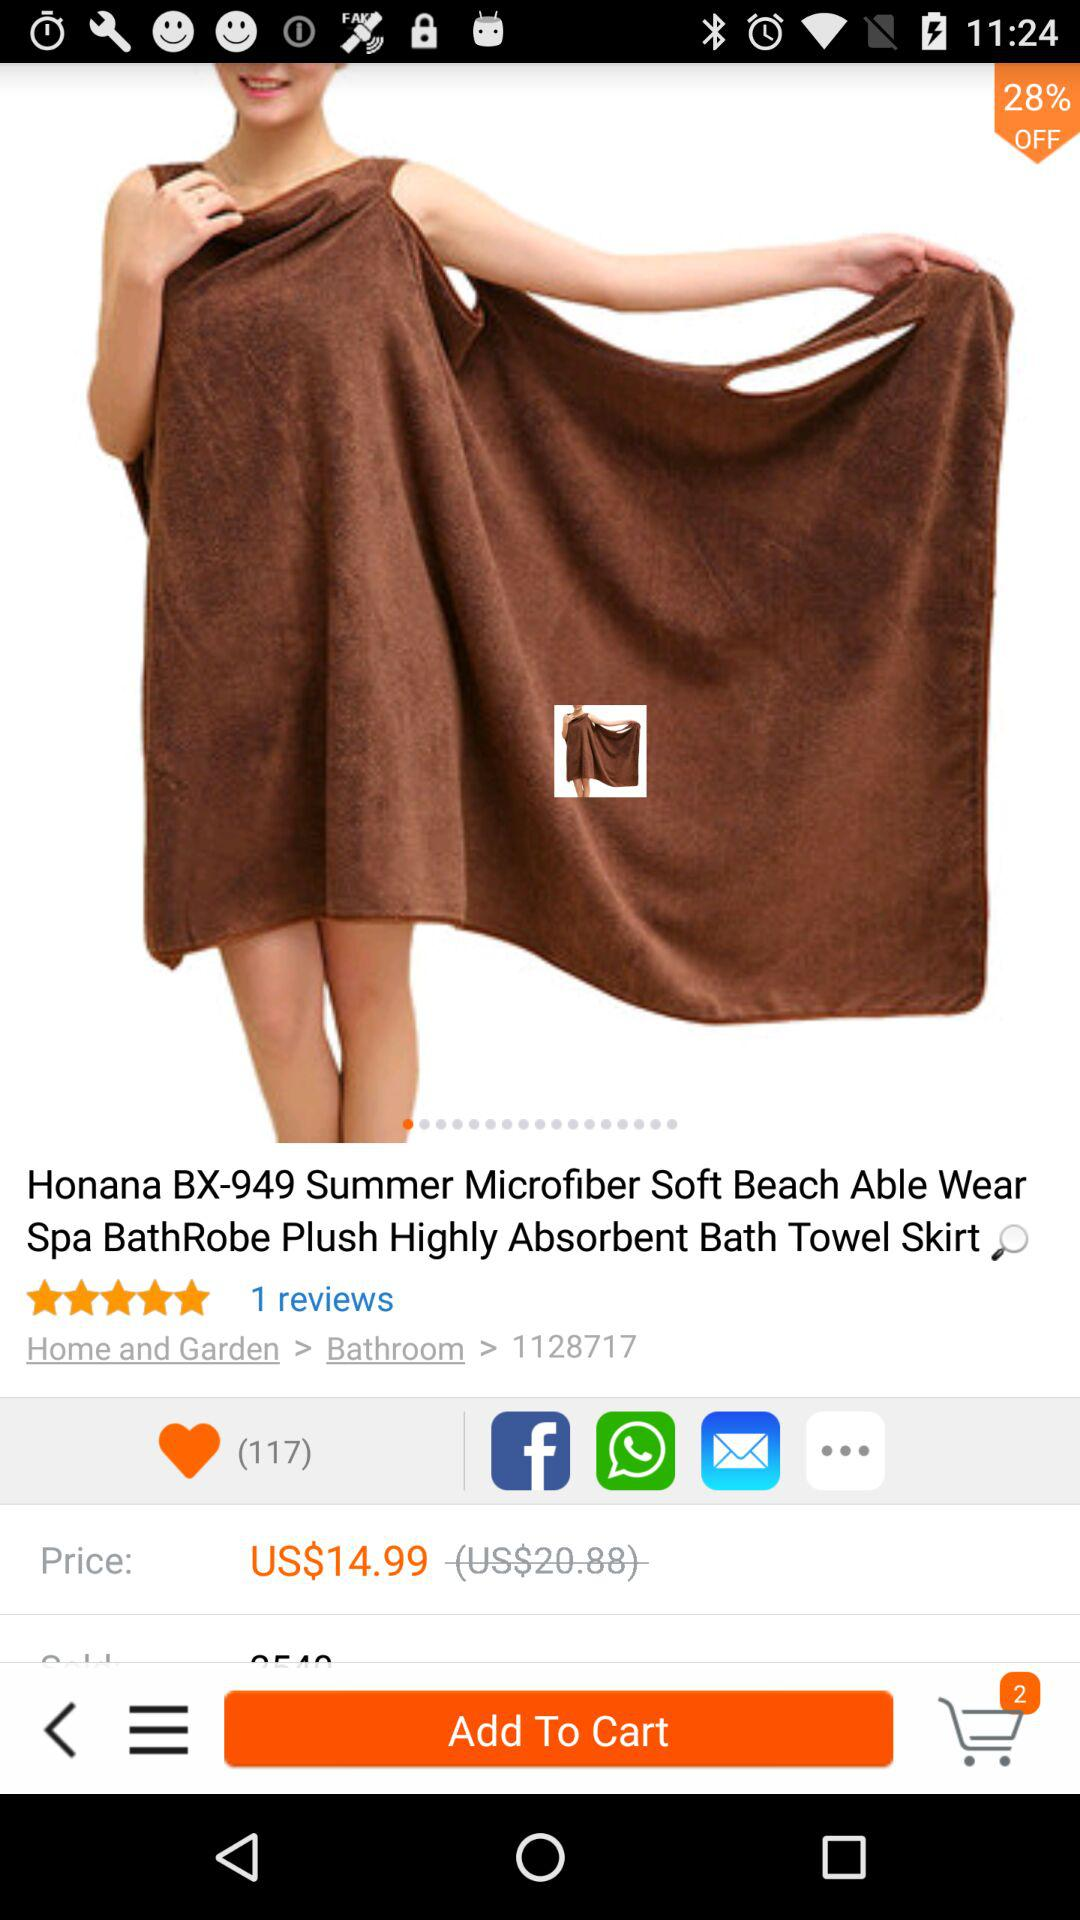What is the discount? The discount is 28%. 